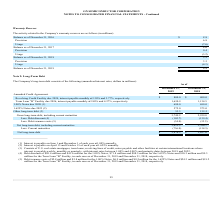According to On Semiconductor's financial document, How much Interest is payable on June 1 and December 1 of each year? According to the financial document, 1.00% annually.. The relevant text states: "s payable on June 1 and December 1 of each year at 1.00% annually. (2) Interest is payable on April 15 and October 15 of each year at 1.625% annually. (3) Consists of..." Also, How much Interest is payable on April 15 and October 15 of each year? According to the financial document, 1.625% annually. The relevant text states: "ayable on April 15 and October 15 of each year at 1.625% annually. (3) Consists of U.S. real estate mortgages, term loans, revolving lines of credit, notes payable a..." Also, What is the net long-term debt for 2019? According to the financial document, $2,876.5 (in millions). The relevant text states: "Net long-term debt $ 2,876.5 $ 2,627.6..." Also, can you calculate: What is the change in Gross long-term debt, including current maturities from December 31, 2018 to 2019? Based on the calculation: 3,749.2-2,939.0, the result is 810.2 (in millions). This is based on the information: "ross long-term debt, including current maturities 3,749.2 2,939.0 g-term debt, including current maturities 3,749.2 2,939.0..." The key data points involved are: 2,939.0, 3,749.2. Also, can you calculate: What is the change in Net long-term debt, including current maturities from year ended December 31, 2018 to 2019? Based on the calculation: 3,612.5-2,766.1, the result is 846.4 (in millions). This is based on the information: "Net long-term debt, including current maturities 3,612.5 2,766.1 g-term debt, including current maturities 3,612.5 2,766.1..." The key data points involved are: 2,766.1, 3,612.5. Also, can you calculate: What is the average Gross long-term debt, including current maturities for December 31, 2018 to 2019? To answer this question, I need to perform calculations using the financial data. The calculation is: (3,749.2+2,939.0) / 2, which equals 3344.1 (in millions). This is based on the information: "ross long-term debt, including current maturities 3,749.2 2,939.0 g-term debt, including current maturities 3,749.2 2,939.0..." The key data points involved are: 2,939.0, 3,749.2. 